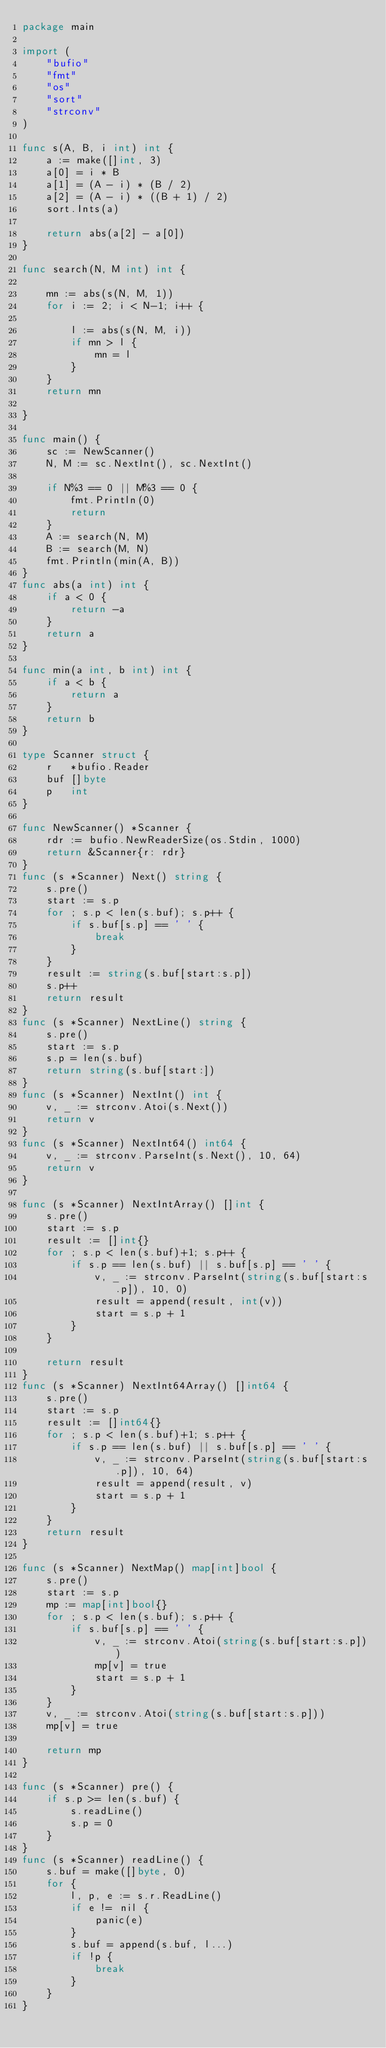Convert code to text. <code><loc_0><loc_0><loc_500><loc_500><_Go_>package main

import (
	"bufio"
	"fmt"
	"os"
	"sort"
	"strconv"
)

func s(A, B, i int) int {
	a := make([]int, 3)
	a[0] = i * B
	a[1] = (A - i) * (B / 2)
	a[2] = (A - i) * ((B + 1) / 2)
	sort.Ints(a)

	return abs(a[2] - a[0])
}

func search(N, M int) int {

	mn := abs(s(N, M, 1))
	for i := 2; i < N-1; i++ {

		l := abs(s(N, M, i))
		if mn > l {
			mn = l
		}
	}
	return mn

}

func main() {
	sc := NewScanner()
	N, M := sc.NextInt(), sc.NextInt()

	if N%3 == 0 || M%3 == 0 {
		fmt.Println(0)
		return
	}
	A := search(N, M)
	B := search(M, N)
	fmt.Println(min(A, B))
}
func abs(a int) int {
	if a < 0 {
		return -a
	}
	return a
}

func min(a int, b int) int {
	if a < b {
		return a
	}
	return b
}

type Scanner struct {
	r   *bufio.Reader
	buf []byte
	p   int
}

func NewScanner() *Scanner {
	rdr := bufio.NewReaderSize(os.Stdin, 1000)
	return &Scanner{r: rdr}
}
func (s *Scanner) Next() string {
	s.pre()
	start := s.p
	for ; s.p < len(s.buf); s.p++ {
		if s.buf[s.p] == ' ' {
			break
		}
	}
	result := string(s.buf[start:s.p])
	s.p++
	return result
}
func (s *Scanner) NextLine() string {
	s.pre()
	start := s.p
	s.p = len(s.buf)
	return string(s.buf[start:])
}
func (s *Scanner) NextInt() int {
	v, _ := strconv.Atoi(s.Next())
	return v
}
func (s *Scanner) NextInt64() int64 {
	v, _ := strconv.ParseInt(s.Next(), 10, 64)
	return v
}

func (s *Scanner) NextIntArray() []int {
	s.pre()
	start := s.p
	result := []int{}
	for ; s.p < len(s.buf)+1; s.p++ {
		if s.p == len(s.buf) || s.buf[s.p] == ' ' {
			v, _ := strconv.ParseInt(string(s.buf[start:s.p]), 10, 0)
			result = append(result, int(v))
			start = s.p + 1
		}
	}

	return result
}
func (s *Scanner) NextInt64Array() []int64 {
	s.pre()
	start := s.p
	result := []int64{}
	for ; s.p < len(s.buf)+1; s.p++ {
		if s.p == len(s.buf) || s.buf[s.p] == ' ' {
			v, _ := strconv.ParseInt(string(s.buf[start:s.p]), 10, 64)
			result = append(result, v)
			start = s.p + 1
		}
	}
	return result
}

func (s *Scanner) NextMap() map[int]bool {
	s.pre()
	start := s.p
	mp := map[int]bool{}
	for ; s.p < len(s.buf); s.p++ {
		if s.buf[s.p] == ' ' {
			v, _ := strconv.Atoi(string(s.buf[start:s.p]))
			mp[v] = true
			start = s.p + 1
		}
	}
	v, _ := strconv.Atoi(string(s.buf[start:s.p]))
	mp[v] = true

	return mp
}

func (s *Scanner) pre() {
	if s.p >= len(s.buf) {
		s.readLine()
		s.p = 0
	}
}
func (s *Scanner) readLine() {
	s.buf = make([]byte, 0)
	for {
		l, p, e := s.r.ReadLine()
		if e != nil {
			panic(e)
		}
		s.buf = append(s.buf, l...)
		if !p {
			break
		}
	}
}
</code> 